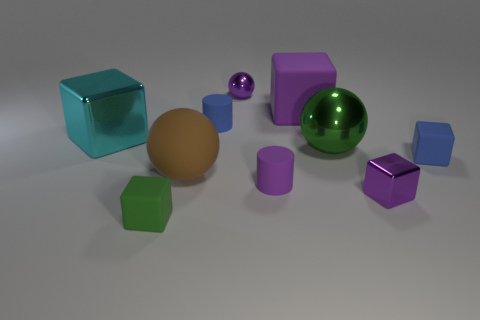Subtract all small metal blocks. How many blocks are left? 4 Subtract all cyan blocks. How many blocks are left? 4 Subtract all cyan blocks. Subtract all green cylinders. How many blocks are left? 4 Subtract all cylinders. How many objects are left? 8 Add 1 small cyan spheres. How many small cyan spheres exist? 1 Subtract 0 yellow cylinders. How many objects are left? 10 Subtract all small rubber cylinders. Subtract all purple matte spheres. How many objects are left? 8 Add 5 purple metal balls. How many purple metal balls are left? 6 